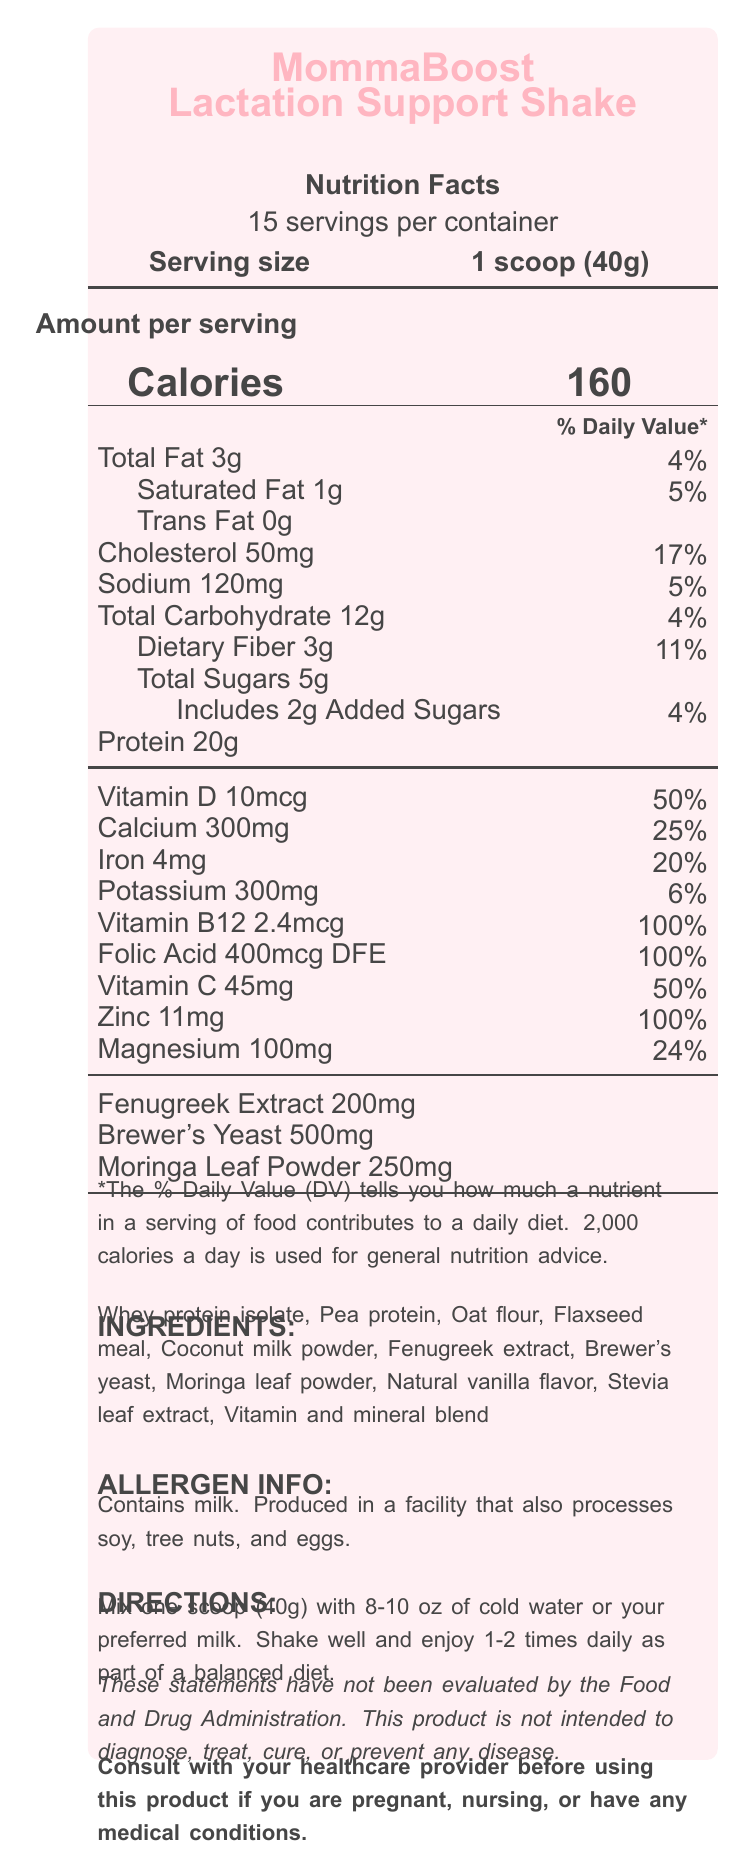What is the serving size of MommaBoost Lactation Support Shake? The serving size is specified as "1 scoop (40g)" in the document.
Answer: 1 scoop (40g) How many calories are in a single serving? The "Amount per serving" section lists the calories as "160".
Answer: 160 calories What percentage of daily Vitamin B12 does one serving provide? The Nutrition Facts indicates that one serving provides "Vitamin B12 2.4mcg", which is "100%" of the daily value.
Answer: 100% What are the main ingredients in the shake? The Ingredients section lists all major components.
Answer: Whey protein isolate, Pea protein, Oat flour, Flaxseed meal, Coconut milk powder, Fenugreek extract, Brewer's yeast, Moringa leaf powder, Natural vanilla flavor, Stevia leaf extract, Vitamin and mineral blend How much protein is in one serving of the shake? The nutrition facts section shows that one serving includes "Protein 20g".
Answer: 20g Does this product contain any tree nuts? The allergen info states the product is manufactured in a facility that processes tree nuts, but it does not specify if the product itself contains tree nuts.
Answer: Cannot be determined How should the product be stored after opening? The storage instructions mention to "Refrigerate after opening and use within 30 days".
Answer: Refrigerate after opening and use within 30 days What percentage of the daily value of Iron is in one serving? A. 10% B. 20% C. 30% D. 50% The Iron content is listed as "4mg", which equates to "20%" of the daily value.
Answer: B. 20% How often should you consume this shake? A. Once daily B. 1-2 times daily C. 2-3 times daily D. Only as recommended by a doctor The directions suggest consuming "1-2 times daily as part of a balanced diet".
Answer: B. 1-2 times daily Is it safe for pregnant women to use this product without consulting a doctor? The document advises to "Consult with your healthcare provider before using this product if you are pregnant, nursing, or have any medical conditions."
Answer: No Identify the vitamins and minerals with the highest percentage of the daily value in this product. The vitamins and minerals section shows Vitamin B12, Folic Acid, and Zinc each at 100% of the daily value.
Answer: Vitamin B12, Folic Acid, Zinc (all 100%) Is there any Trans Fat in this shake? The nutrition facts section lists "Trans Fat 0g".
Answer: No Summarize the main nutritional aspects of MommaBoost Lactation Support Shake. The shake offers comprehensive nutritional support with a strong focus on protein and essential vitamins and minerals, as well as specific lactation-supporting ingredients. It also includes storage instructions and allergy information.
Answer: MommaBoost Lactation Support Shake provides 160 calories per serving. It includes 20g of protein, 3g of dietary fiber, and key vitamins and minerals such as Vitamin D, Calcium, Iron, Vitamin B12, Folic Acid, Vitamin C, Zinc, and Magnesium. It's designed to support lactation with added ingredients like Fenugreek Extract, Brewer's Yeast, and Moringa Leaf Powder. The product also has allergen information and storage guidelines. What is the flavoring agent used in this product? The ingredients list includes "Natural vanilla flavor".
Answer: Natural vanilla flavor Which of the following best describes the macronutrient composition of one serving of this product? A. High in fat, low in protein B. High in protein, low in carbohydrates C. High in carbohydrates, low in fat D. Balanced macronutrients The product contains 20g of protein, 12g of carbohydrates, and 3g of fat per serving.
Answer: B. High in protein, low in carbohydrates What is the daily value percentage of saturated fat in one serving? Saturated fat is listed as "1g", which is "5%" of the daily value.
Answer: 5% 